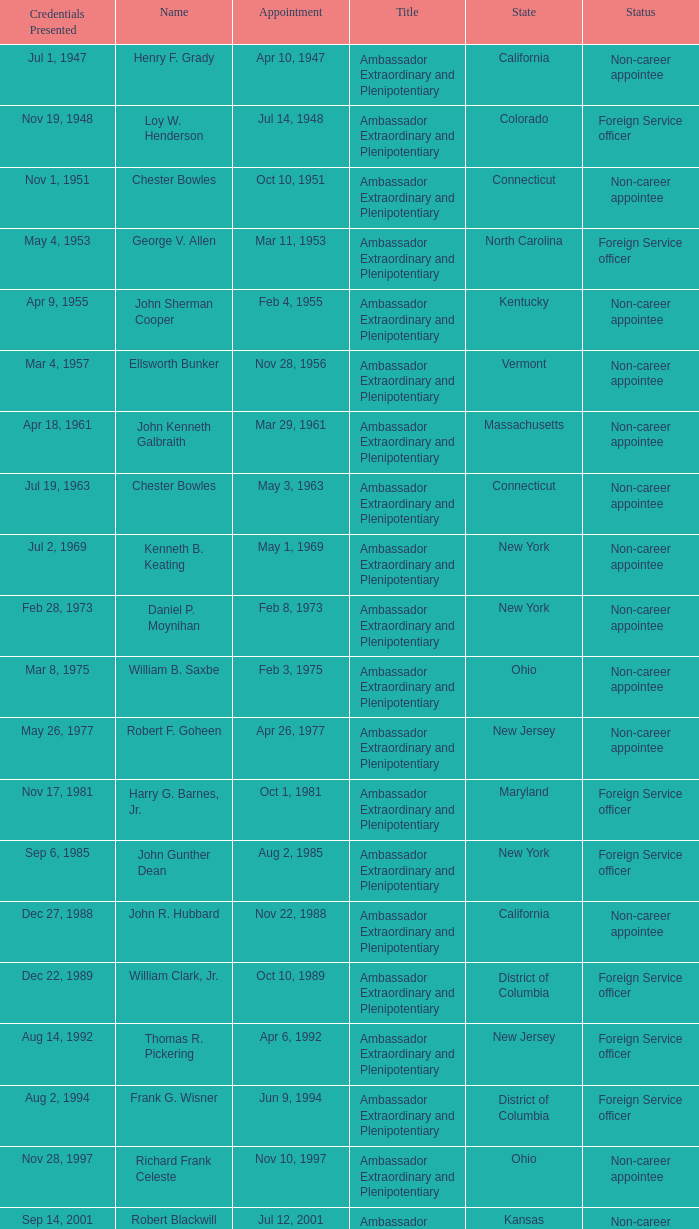What day were credentials presented for vermont? Mar 4, 1957. 